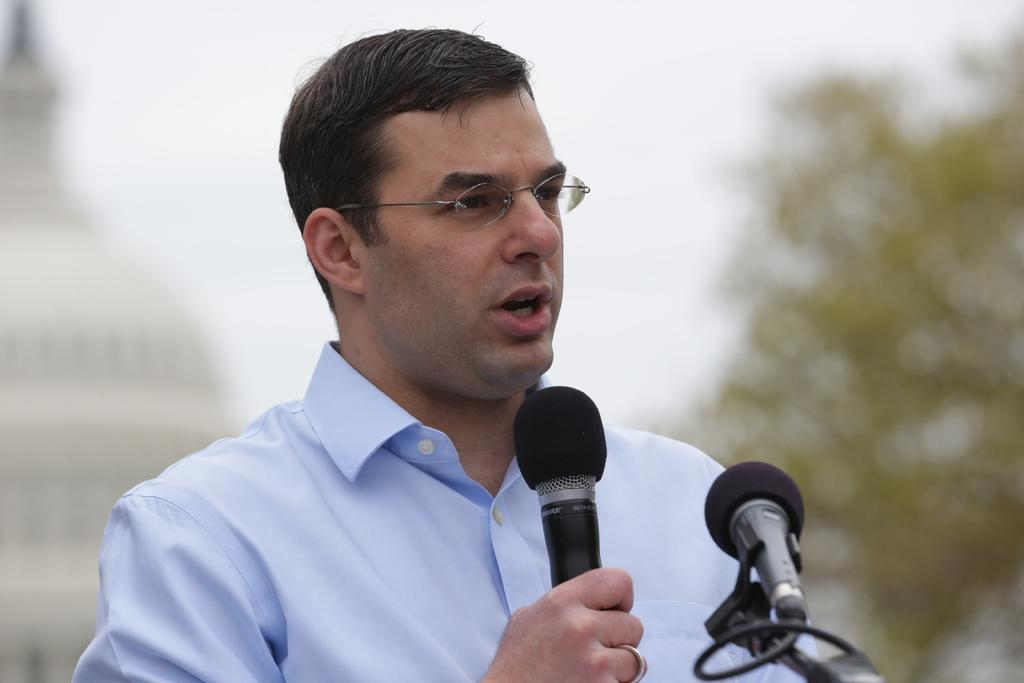Who is the person in the image? There is a man in the image. What is the man holding in his hand? The man is holding a mic in his hand. Are there any other mics visible in the image? Yes, there is another mic in the image. What can be seen in the background of the image? There is a tree and a building in the background of the image. What type of match is the man participating in the image? There is no match or competition present in the image; it only shows a man holding a mic and another mic nearby. 